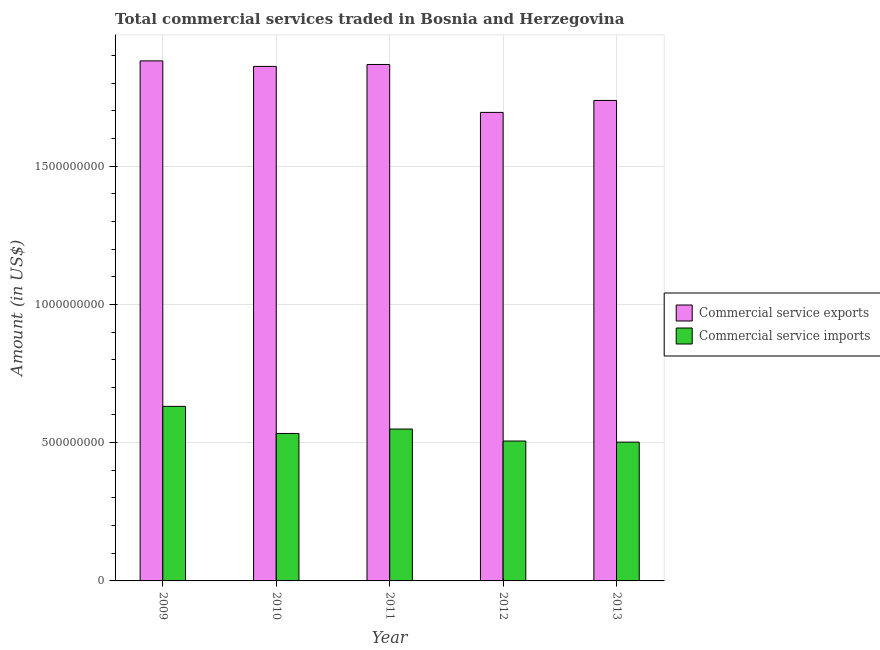How many different coloured bars are there?
Offer a very short reply. 2. How many bars are there on the 4th tick from the left?
Your answer should be compact. 2. How many bars are there on the 5th tick from the right?
Offer a very short reply. 2. What is the amount of commercial service exports in 2009?
Provide a succinct answer. 1.88e+09. Across all years, what is the maximum amount of commercial service imports?
Ensure brevity in your answer.  6.31e+08. Across all years, what is the minimum amount of commercial service imports?
Offer a very short reply. 5.02e+08. In which year was the amount of commercial service exports maximum?
Your answer should be compact. 2009. In which year was the amount of commercial service imports minimum?
Keep it short and to the point. 2013. What is the total amount of commercial service imports in the graph?
Make the answer very short. 2.72e+09. What is the difference between the amount of commercial service imports in 2009 and that in 2012?
Make the answer very short. 1.25e+08. What is the difference between the amount of commercial service exports in 2012 and the amount of commercial service imports in 2010?
Your answer should be very brief. -1.66e+08. What is the average amount of commercial service exports per year?
Your answer should be compact. 1.81e+09. In the year 2012, what is the difference between the amount of commercial service exports and amount of commercial service imports?
Keep it short and to the point. 0. What is the ratio of the amount of commercial service imports in 2010 to that in 2012?
Make the answer very short. 1.05. What is the difference between the highest and the second highest amount of commercial service imports?
Ensure brevity in your answer.  8.19e+07. What is the difference between the highest and the lowest amount of commercial service exports?
Offer a terse response. 1.86e+08. In how many years, is the amount of commercial service imports greater than the average amount of commercial service imports taken over all years?
Your response must be concise. 2. What does the 1st bar from the left in 2011 represents?
Your answer should be compact. Commercial service exports. What does the 2nd bar from the right in 2012 represents?
Give a very brief answer. Commercial service exports. How many years are there in the graph?
Make the answer very short. 5. Are the values on the major ticks of Y-axis written in scientific E-notation?
Provide a short and direct response. No. Where does the legend appear in the graph?
Give a very brief answer. Center right. How are the legend labels stacked?
Your answer should be compact. Vertical. What is the title of the graph?
Provide a succinct answer. Total commercial services traded in Bosnia and Herzegovina. What is the label or title of the X-axis?
Your answer should be very brief. Year. What is the label or title of the Y-axis?
Offer a terse response. Amount (in US$). What is the Amount (in US$) of Commercial service exports in 2009?
Provide a short and direct response. 1.88e+09. What is the Amount (in US$) of Commercial service imports in 2009?
Your response must be concise. 6.31e+08. What is the Amount (in US$) of Commercial service exports in 2010?
Provide a succinct answer. 1.86e+09. What is the Amount (in US$) of Commercial service imports in 2010?
Provide a succinct answer. 5.33e+08. What is the Amount (in US$) in Commercial service exports in 2011?
Give a very brief answer. 1.87e+09. What is the Amount (in US$) in Commercial service imports in 2011?
Give a very brief answer. 5.49e+08. What is the Amount (in US$) in Commercial service exports in 2012?
Your answer should be compact. 1.69e+09. What is the Amount (in US$) in Commercial service imports in 2012?
Provide a short and direct response. 5.06e+08. What is the Amount (in US$) of Commercial service exports in 2013?
Give a very brief answer. 1.74e+09. What is the Amount (in US$) of Commercial service imports in 2013?
Give a very brief answer. 5.02e+08. Across all years, what is the maximum Amount (in US$) of Commercial service exports?
Offer a very short reply. 1.88e+09. Across all years, what is the maximum Amount (in US$) of Commercial service imports?
Make the answer very short. 6.31e+08. Across all years, what is the minimum Amount (in US$) of Commercial service exports?
Keep it short and to the point. 1.69e+09. Across all years, what is the minimum Amount (in US$) of Commercial service imports?
Keep it short and to the point. 5.02e+08. What is the total Amount (in US$) in Commercial service exports in the graph?
Give a very brief answer. 9.04e+09. What is the total Amount (in US$) in Commercial service imports in the graph?
Keep it short and to the point. 2.72e+09. What is the difference between the Amount (in US$) in Commercial service exports in 2009 and that in 2010?
Provide a short and direct response. 2.00e+07. What is the difference between the Amount (in US$) in Commercial service imports in 2009 and that in 2010?
Keep it short and to the point. 9.80e+07. What is the difference between the Amount (in US$) of Commercial service exports in 2009 and that in 2011?
Your answer should be very brief. 1.30e+07. What is the difference between the Amount (in US$) in Commercial service imports in 2009 and that in 2011?
Make the answer very short. 8.19e+07. What is the difference between the Amount (in US$) in Commercial service exports in 2009 and that in 2012?
Offer a terse response. 1.86e+08. What is the difference between the Amount (in US$) in Commercial service imports in 2009 and that in 2012?
Your response must be concise. 1.25e+08. What is the difference between the Amount (in US$) of Commercial service exports in 2009 and that in 2013?
Ensure brevity in your answer.  1.43e+08. What is the difference between the Amount (in US$) of Commercial service imports in 2009 and that in 2013?
Offer a terse response. 1.29e+08. What is the difference between the Amount (in US$) in Commercial service exports in 2010 and that in 2011?
Your answer should be very brief. -7.01e+06. What is the difference between the Amount (in US$) in Commercial service imports in 2010 and that in 2011?
Give a very brief answer. -1.61e+07. What is the difference between the Amount (in US$) in Commercial service exports in 2010 and that in 2012?
Keep it short and to the point. 1.66e+08. What is the difference between the Amount (in US$) in Commercial service imports in 2010 and that in 2012?
Make the answer very short. 2.72e+07. What is the difference between the Amount (in US$) in Commercial service exports in 2010 and that in 2013?
Your response must be concise. 1.23e+08. What is the difference between the Amount (in US$) of Commercial service imports in 2010 and that in 2013?
Your answer should be compact. 3.13e+07. What is the difference between the Amount (in US$) in Commercial service exports in 2011 and that in 2012?
Keep it short and to the point. 1.73e+08. What is the difference between the Amount (in US$) in Commercial service imports in 2011 and that in 2012?
Keep it short and to the point. 4.33e+07. What is the difference between the Amount (in US$) in Commercial service exports in 2011 and that in 2013?
Your answer should be very brief. 1.30e+08. What is the difference between the Amount (in US$) of Commercial service imports in 2011 and that in 2013?
Give a very brief answer. 4.74e+07. What is the difference between the Amount (in US$) of Commercial service exports in 2012 and that in 2013?
Provide a short and direct response. -4.32e+07. What is the difference between the Amount (in US$) in Commercial service imports in 2012 and that in 2013?
Your response must be concise. 4.03e+06. What is the difference between the Amount (in US$) in Commercial service exports in 2009 and the Amount (in US$) in Commercial service imports in 2010?
Keep it short and to the point. 1.35e+09. What is the difference between the Amount (in US$) in Commercial service exports in 2009 and the Amount (in US$) in Commercial service imports in 2011?
Your response must be concise. 1.33e+09. What is the difference between the Amount (in US$) in Commercial service exports in 2009 and the Amount (in US$) in Commercial service imports in 2012?
Provide a short and direct response. 1.37e+09. What is the difference between the Amount (in US$) in Commercial service exports in 2009 and the Amount (in US$) in Commercial service imports in 2013?
Ensure brevity in your answer.  1.38e+09. What is the difference between the Amount (in US$) in Commercial service exports in 2010 and the Amount (in US$) in Commercial service imports in 2011?
Ensure brevity in your answer.  1.31e+09. What is the difference between the Amount (in US$) in Commercial service exports in 2010 and the Amount (in US$) in Commercial service imports in 2012?
Give a very brief answer. 1.35e+09. What is the difference between the Amount (in US$) of Commercial service exports in 2010 and the Amount (in US$) of Commercial service imports in 2013?
Your answer should be compact. 1.36e+09. What is the difference between the Amount (in US$) in Commercial service exports in 2011 and the Amount (in US$) in Commercial service imports in 2012?
Offer a very short reply. 1.36e+09. What is the difference between the Amount (in US$) in Commercial service exports in 2011 and the Amount (in US$) in Commercial service imports in 2013?
Give a very brief answer. 1.37e+09. What is the difference between the Amount (in US$) in Commercial service exports in 2012 and the Amount (in US$) in Commercial service imports in 2013?
Ensure brevity in your answer.  1.19e+09. What is the average Amount (in US$) of Commercial service exports per year?
Provide a short and direct response. 1.81e+09. What is the average Amount (in US$) of Commercial service imports per year?
Offer a terse response. 5.44e+08. In the year 2009, what is the difference between the Amount (in US$) of Commercial service exports and Amount (in US$) of Commercial service imports?
Keep it short and to the point. 1.25e+09. In the year 2010, what is the difference between the Amount (in US$) of Commercial service exports and Amount (in US$) of Commercial service imports?
Offer a very short reply. 1.33e+09. In the year 2011, what is the difference between the Amount (in US$) of Commercial service exports and Amount (in US$) of Commercial service imports?
Keep it short and to the point. 1.32e+09. In the year 2012, what is the difference between the Amount (in US$) of Commercial service exports and Amount (in US$) of Commercial service imports?
Offer a terse response. 1.19e+09. In the year 2013, what is the difference between the Amount (in US$) of Commercial service exports and Amount (in US$) of Commercial service imports?
Provide a short and direct response. 1.24e+09. What is the ratio of the Amount (in US$) in Commercial service exports in 2009 to that in 2010?
Provide a succinct answer. 1.01. What is the ratio of the Amount (in US$) of Commercial service imports in 2009 to that in 2010?
Your answer should be compact. 1.18. What is the ratio of the Amount (in US$) in Commercial service exports in 2009 to that in 2011?
Offer a very short reply. 1.01. What is the ratio of the Amount (in US$) in Commercial service imports in 2009 to that in 2011?
Your response must be concise. 1.15. What is the ratio of the Amount (in US$) of Commercial service exports in 2009 to that in 2012?
Your response must be concise. 1.11. What is the ratio of the Amount (in US$) in Commercial service imports in 2009 to that in 2012?
Offer a terse response. 1.25. What is the ratio of the Amount (in US$) in Commercial service exports in 2009 to that in 2013?
Provide a succinct answer. 1.08. What is the ratio of the Amount (in US$) of Commercial service imports in 2009 to that in 2013?
Ensure brevity in your answer.  1.26. What is the ratio of the Amount (in US$) of Commercial service imports in 2010 to that in 2011?
Provide a succinct answer. 0.97. What is the ratio of the Amount (in US$) in Commercial service exports in 2010 to that in 2012?
Make the answer very short. 1.1. What is the ratio of the Amount (in US$) of Commercial service imports in 2010 to that in 2012?
Ensure brevity in your answer.  1.05. What is the ratio of the Amount (in US$) of Commercial service exports in 2010 to that in 2013?
Your answer should be very brief. 1.07. What is the ratio of the Amount (in US$) in Commercial service imports in 2010 to that in 2013?
Offer a terse response. 1.06. What is the ratio of the Amount (in US$) in Commercial service exports in 2011 to that in 2012?
Provide a short and direct response. 1.1. What is the ratio of the Amount (in US$) of Commercial service imports in 2011 to that in 2012?
Keep it short and to the point. 1.09. What is the ratio of the Amount (in US$) in Commercial service exports in 2011 to that in 2013?
Give a very brief answer. 1.07. What is the ratio of the Amount (in US$) in Commercial service imports in 2011 to that in 2013?
Offer a very short reply. 1.09. What is the ratio of the Amount (in US$) of Commercial service exports in 2012 to that in 2013?
Ensure brevity in your answer.  0.98. What is the difference between the highest and the second highest Amount (in US$) of Commercial service exports?
Provide a short and direct response. 1.30e+07. What is the difference between the highest and the second highest Amount (in US$) in Commercial service imports?
Give a very brief answer. 8.19e+07. What is the difference between the highest and the lowest Amount (in US$) of Commercial service exports?
Give a very brief answer. 1.86e+08. What is the difference between the highest and the lowest Amount (in US$) in Commercial service imports?
Provide a succinct answer. 1.29e+08. 